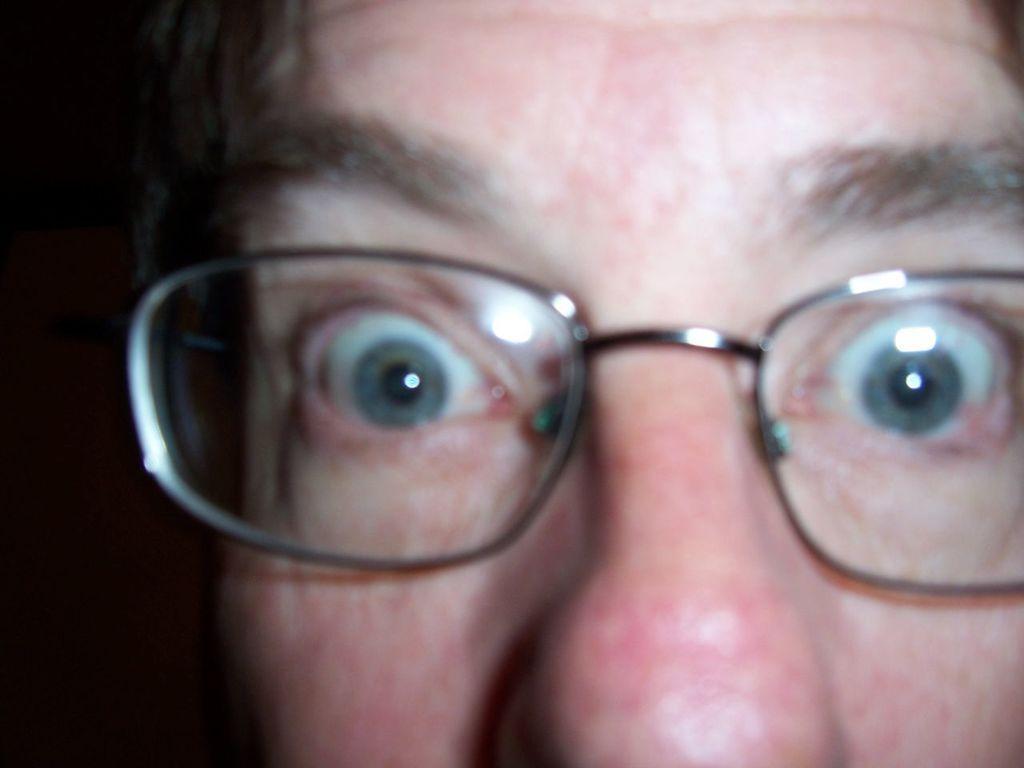Please provide a concise description of this image. In the image we can see there is a face of a person wearing spectacles. 